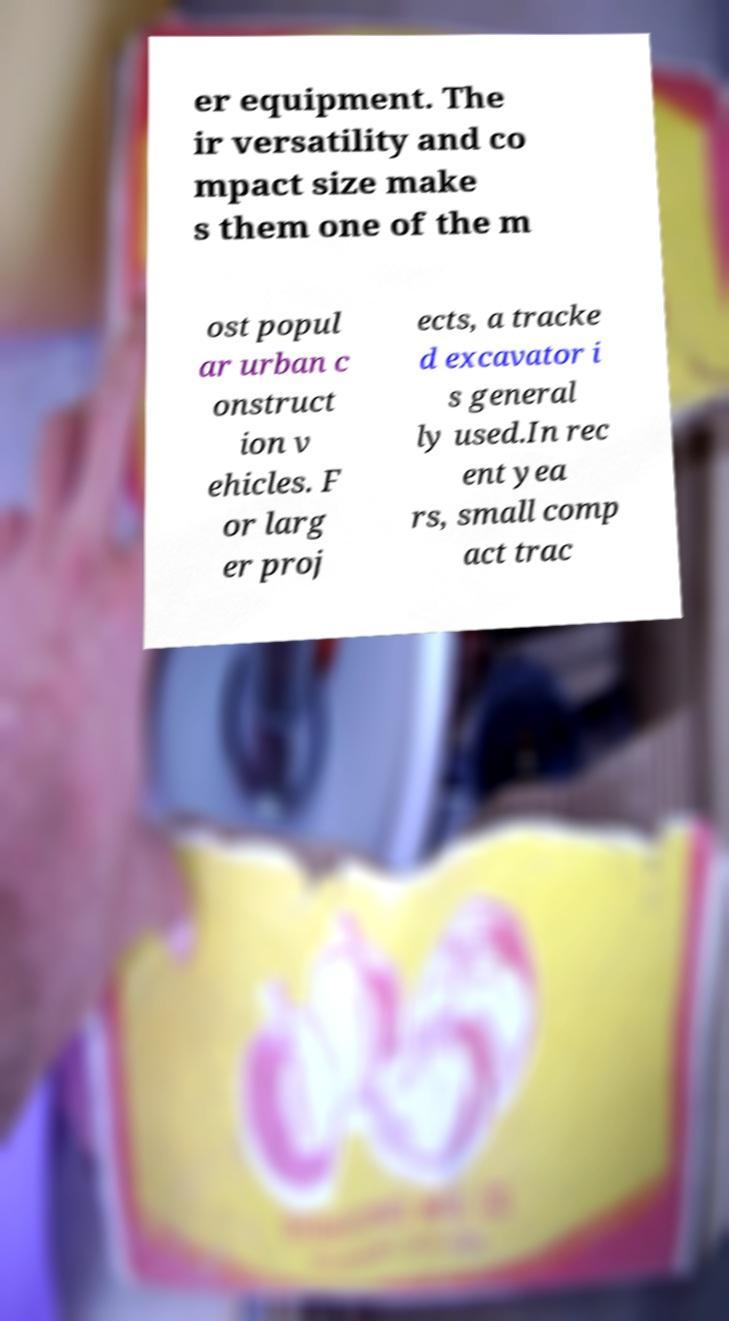For documentation purposes, I need the text within this image transcribed. Could you provide that? er equipment. The ir versatility and co mpact size make s them one of the m ost popul ar urban c onstruct ion v ehicles. F or larg er proj ects, a tracke d excavator i s general ly used.In rec ent yea rs, small comp act trac 